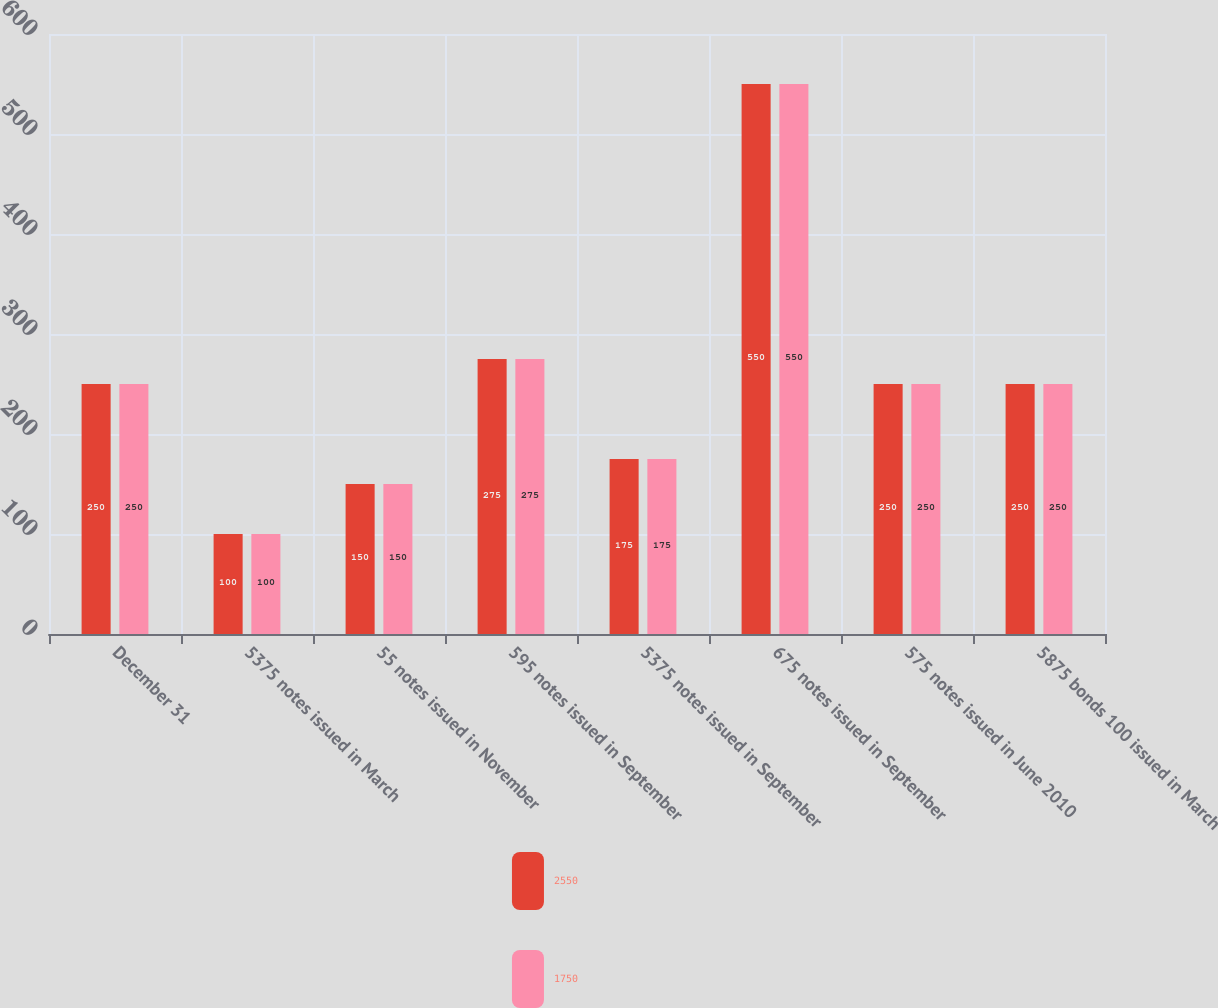Convert chart. <chart><loc_0><loc_0><loc_500><loc_500><stacked_bar_chart><ecel><fcel>December 31<fcel>5375 notes issued in March<fcel>55 notes issued in November<fcel>595 notes issued in September<fcel>5375 notes issued in September<fcel>675 notes issued in September<fcel>575 notes issued in June 2010<fcel>5875 bonds 100 issued in March<nl><fcel>2550<fcel>250<fcel>100<fcel>150<fcel>275<fcel>175<fcel>550<fcel>250<fcel>250<nl><fcel>1750<fcel>250<fcel>100<fcel>150<fcel>275<fcel>175<fcel>550<fcel>250<fcel>250<nl></chart> 